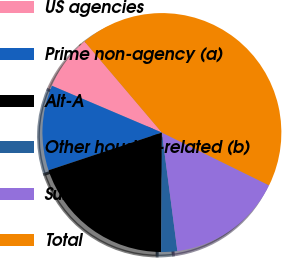Convert chart. <chart><loc_0><loc_0><loc_500><loc_500><pie_chart><fcel>US agencies<fcel>Prime non-agency (a)<fcel>Alt-A<fcel>Other housing-related (b)<fcel>Subprime<fcel>Total<nl><fcel>7.39%<fcel>11.52%<fcel>19.78%<fcel>2.17%<fcel>15.65%<fcel>43.48%<nl></chart> 